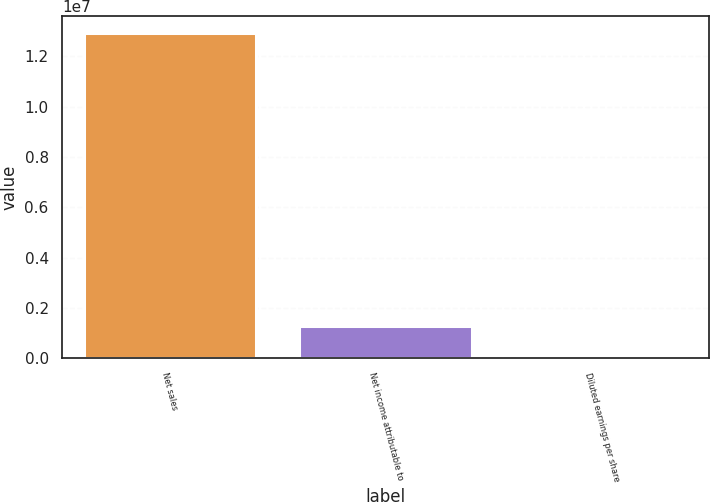Convert chart to OTSL. <chart><loc_0><loc_0><loc_500><loc_500><bar_chart><fcel>Net sales<fcel>Net income attributable to<fcel>Diluted earnings per share<nl><fcel>1.29358e+07<fcel>1.29359e+06<fcel>7.58<nl></chart> 